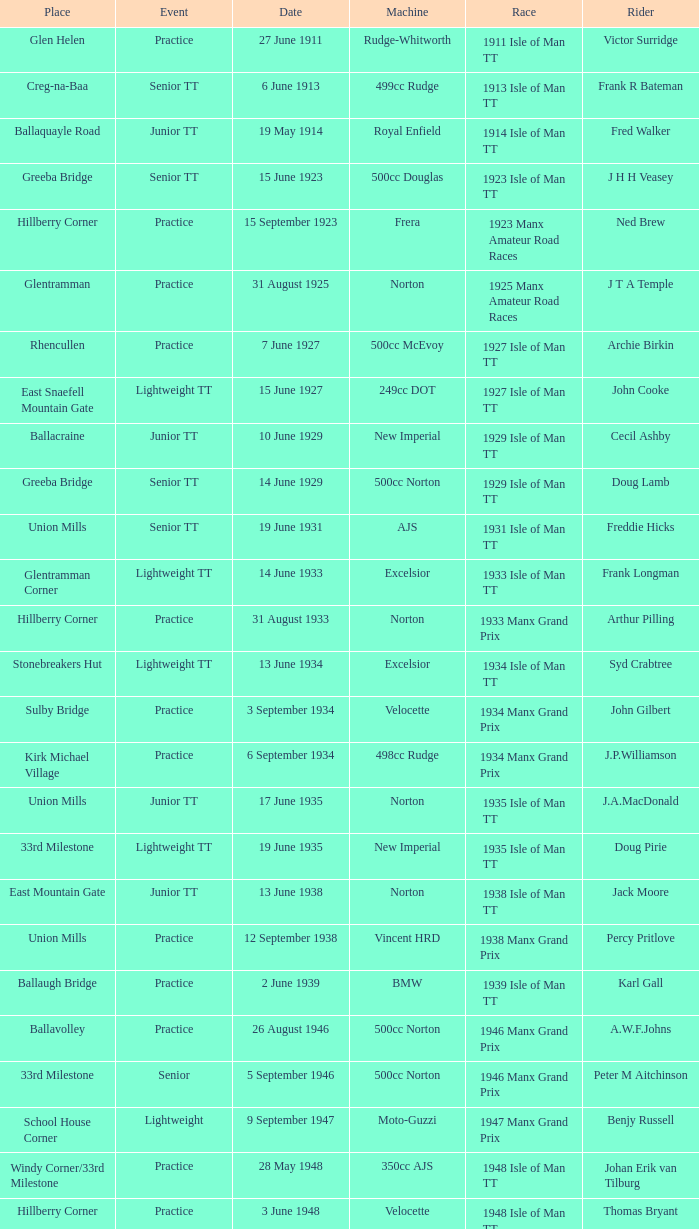What event was Rob Vine riding? Senior TT. 